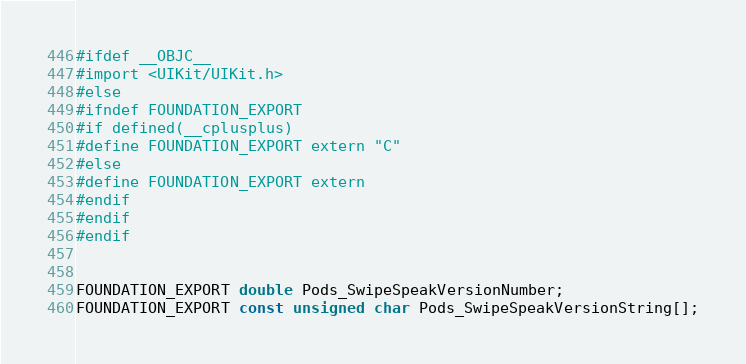<code> <loc_0><loc_0><loc_500><loc_500><_C_>#ifdef __OBJC__
#import <UIKit/UIKit.h>
#else
#ifndef FOUNDATION_EXPORT
#if defined(__cplusplus)
#define FOUNDATION_EXPORT extern "C"
#else
#define FOUNDATION_EXPORT extern
#endif
#endif
#endif


FOUNDATION_EXPORT double Pods_SwipeSpeakVersionNumber;
FOUNDATION_EXPORT const unsigned char Pods_SwipeSpeakVersionString[];

</code> 